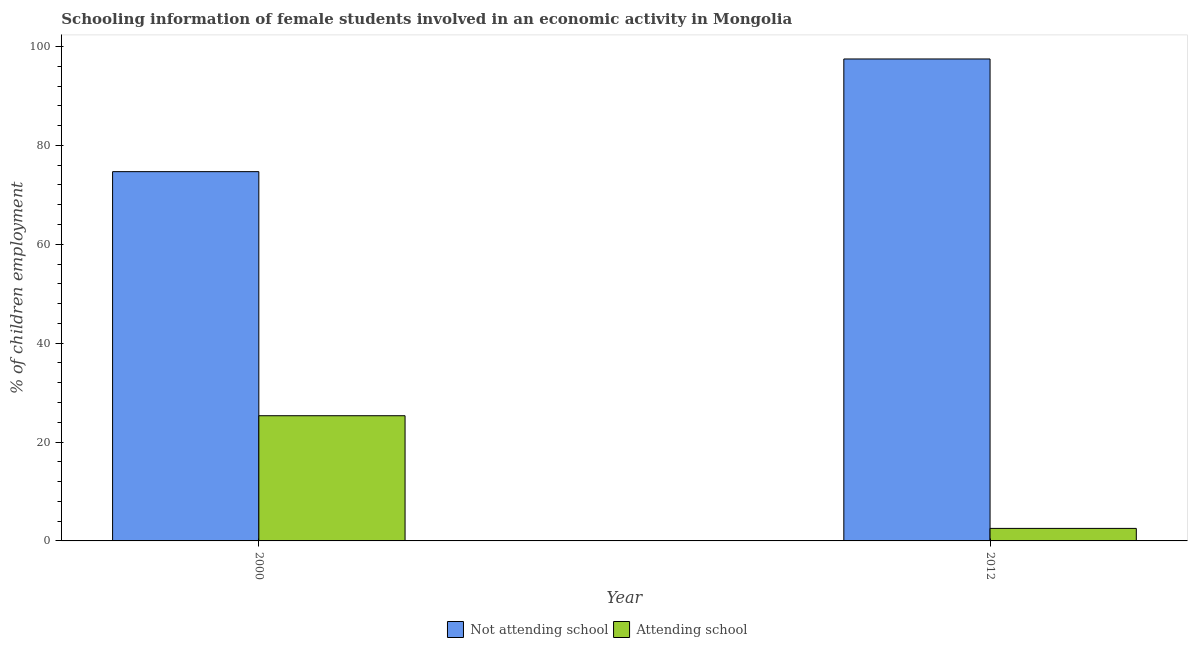How many groups of bars are there?
Keep it short and to the point. 2. Are the number of bars per tick equal to the number of legend labels?
Make the answer very short. Yes. How many bars are there on the 2nd tick from the right?
Give a very brief answer. 2. What is the label of the 1st group of bars from the left?
Keep it short and to the point. 2000. What is the percentage of employed females who are attending school in 2012?
Provide a short and direct response. 2.53. Across all years, what is the maximum percentage of employed females who are not attending school?
Make the answer very short. 97.47. Across all years, what is the minimum percentage of employed females who are not attending school?
Your answer should be compact. 74.68. In which year was the percentage of employed females who are attending school minimum?
Offer a terse response. 2012. What is the total percentage of employed females who are not attending school in the graph?
Your answer should be very brief. 172.15. What is the difference between the percentage of employed females who are not attending school in 2000 and that in 2012?
Ensure brevity in your answer.  -22.79. What is the difference between the percentage of employed females who are not attending school in 2012 and the percentage of employed females who are attending school in 2000?
Provide a succinct answer. 22.79. What is the average percentage of employed females who are attending school per year?
Offer a very short reply. 13.93. What is the ratio of the percentage of employed females who are attending school in 2000 to that in 2012?
Ensure brevity in your answer.  10. Is the percentage of employed females who are not attending school in 2000 less than that in 2012?
Give a very brief answer. Yes. What does the 1st bar from the left in 2012 represents?
Your answer should be very brief. Not attending school. What does the 2nd bar from the right in 2000 represents?
Keep it short and to the point. Not attending school. Are all the bars in the graph horizontal?
Your response must be concise. No. How many years are there in the graph?
Make the answer very short. 2. Are the values on the major ticks of Y-axis written in scientific E-notation?
Make the answer very short. No. Does the graph contain grids?
Your answer should be very brief. No. Where does the legend appear in the graph?
Offer a very short reply. Bottom center. How many legend labels are there?
Your answer should be very brief. 2. How are the legend labels stacked?
Your answer should be very brief. Horizontal. What is the title of the graph?
Your answer should be very brief. Schooling information of female students involved in an economic activity in Mongolia. Does "DAC donors" appear as one of the legend labels in the graph?
Give a very brief answer. No. What is the label or title of the X-axis?
Provide a succinct answer. Year. What is the label or title of the Y-axis?
Your answer should be compact. % of children employment. What is the % of children employment of Not attending school in 2000?
Ensure brevity in your answer.  74.68. What is the % of children employment of Attending school in 2000?
Give a very brief answer. 25.32. What is the % of children employment of Not attending school in 2012?
Provide a succinct answer. 97.47. What is the % of children employment in Attending school in 2012?
Offer a very short reply. 2.53. Across all years, what is the maximum % of children employment of Not attending school?
Ensure brevity in your answer.  97.47. Across all years, what is the maximum % of children employment of Attending school?
Your answer should be very brief. 25.32. Across all years, what is the minimum % of children employment of Not attending school?
Offer a very short reply. 74.68. Across all years, what is the minimum % of children employment of Attending school?
Offer a very short reply. 2.53. What is the total % of children employment in Not attending school in the graph?
Offer a very short reply. 172.15. What is the total % of children employment of Attending school in the graph?
Offer a terse response. 27.85. What is the difference between the % of children employment in Not attending school in 2000 and that in 2012?
Ensure brevity in your answer.  -22.79. What is the difference between the % of children employment in Attending school in 2000 and that in 2012?
Your answer should be very brief. 22.79. What is the difference between the % of children employment in Not attending school in 2000 and the % of children employment in Attending school in 2012?
Give a very brief answer. 72.15. What is the average % of children employment of Not attending school per year?
Offer a very short reply. 86.08. What is the average % of children employment of Attending school per year?
Your answer should be compact. 13.93. In the year 2000, what is the difference between the % of children employment in Not attending school and % of children employment in Attending school?
Offer a terse response. 49.36. In the year 2012, what is the difference between the % of children employment in Not attending school and % of children employment in Attending school?
Your response must be concise. 94.94. What is the ratio of the % of children employment of Not attending school in 2000 to that in 2012?
Your answer should be compact. 0.77. What is the ratio of the % of children employment of Attending school in 2000 to that in 2012?
Offer a very short reply. 10. What is the difference between the highest and the second highest % of children employment in Not attending school?
Ensure brevity in your answer.  22.79. What is the difference between the highest and the second highest % of children employment in Attending school?
Your response must be concise. 22.79. What is the difference between the highest and the lowest % of children employment of Not attending school?
Provide a succinct answer. 22.79. What is the difference between the highest and the lowest % of children employment in Attending school?
Offer a terse response. 22.79. 